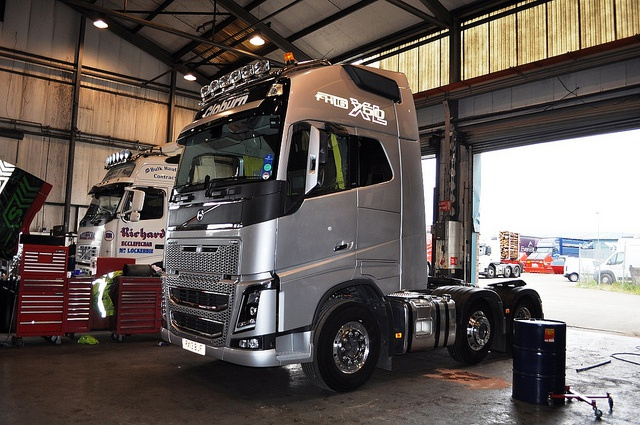Describe the objects in this image and their specific colors. I can see truck in black, gray, darkgray, and lightgray tones, truck in black, darkgray, gray, and tan tones, truck in black, white, darkgray, gray, and salmon tones, and truck in black, white, darkgray, and lightgray tones in this image. 